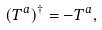<formula> <loc_0><loc_0><loc_500><loc_500>( { T } ^ { a } ) ^ { \dagger } = - { T } ^ { a } ,</formula> 